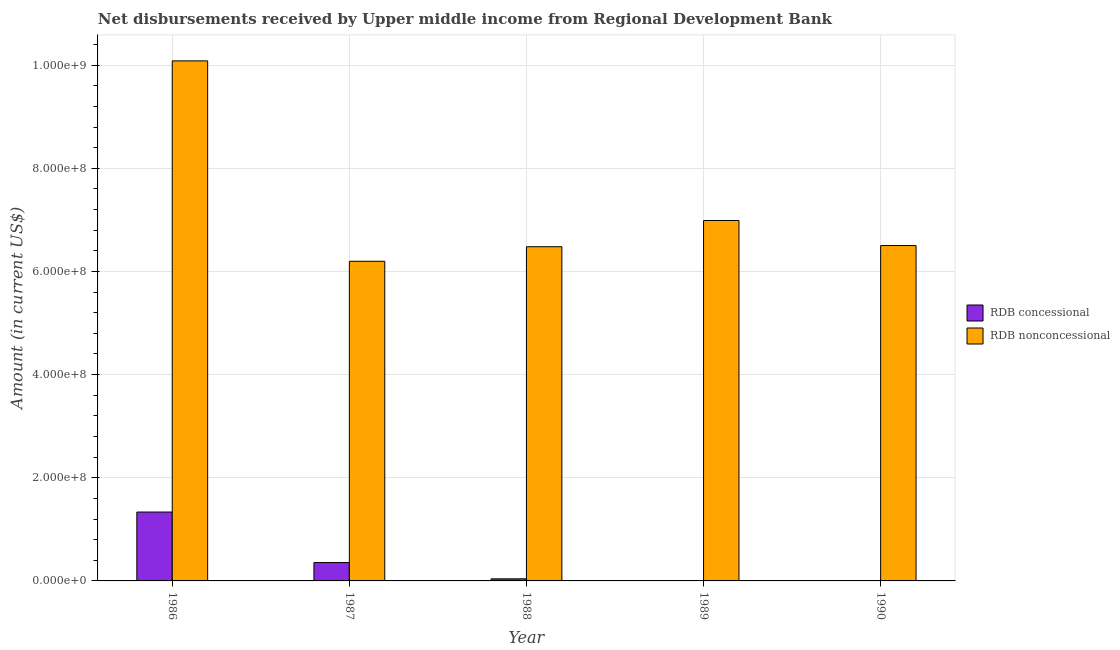How many different coloured bars are there?
Offer a terse response. 2. How many bars are there on the 1st tick from the left?
Provide a succinct answer. 2. In how many cases, is the number of bars for a given year not equal to the number of legend labels?
Ensure brevity in your answer.  2. What is the net concessional disbursements from rdb in 1989?
Offer a very short reply. 0. Across all years, what is the maximum net concessional disbursements from rdb?
Keep it short and to the point. 1.34e+08. Across all years, what is the minimum net concessional disbursements from rdb?
Give a very brief answer. 0. In which year was the net non concessional disbursements from rdb maximum?
Provide a succinct answer. 1986. What is the total net non concessional disbursements from rdb in the graph?
Offer a terse response. 3.62e+09. What is the difference between the net concessional disbursements from rdb in 1986 and that in 1987?
Provide a succinct answer. 9.79e+07. What is the difference between the net non concessional disbursements from rdb in 1988 and the net concessional disbursements from rdb in 1990?
Offer a terse response. -2.28e+06. What is the average net non concessional disbursements from rdb per year?
Ensure brevity in your answer.  7.25e+08. What is the ratio of the net concessional disbursements from rdb in 1987 to that in 1988?
Provide a short and direct response. 8.79. Is the net non concessional disbursements from rdb in 1988 less than that in 1989?
Make the answer very short. Yes. What is the difference between the highest and the second highest net non concessional disbursements from rdb?
Provide a succinct answer. 3.09e+08. What is the difference between the highest and the lowest net concessional disbursements from rdb?
Give a very brief answer. 1.34e+08. Are all the bars in the graph horizontal?
Your answer should be very brief. No. Where does the legend appear in the graph?
Your response must be concise. Center right. How many legend labels are there?
Ensure brevity in your answer.  2. How are the legend labels stacked?
Make the answer very short. Vertical. What is the title of the graph?
Your response must be concise. Net disbursements received by Upper middle income from Regional Development Bank. What is the Amount (in current US$) in RDB concessional in 1986?
Your answer should be compact. 1.34e+08. What is the Amount (in current US$) of RDB nonconcessional in 1986?
Make the answer very short. 1.01e+09. What is the Amount (in current US$) of RDB concessional in 1987?
Make the answer very short. 3.56e+07. What is the Amount (in current US$) of RDB nonconcessional in 1987?
Give a very brief answer. 6.20e+08. What is the Amount (in current US$) in RDB concessional in 1988?
Offer a terse response. 4.05e+06. What is the Amount (in current US$) of RDB nonconcessional in 1988?
Offer a very short reply. 6.48e+08. What is the Amount (in current US$) in RDB nonconcessional in 1989?
Keep it short and to the point. 6.99e+08. What is the Amount (in current US$) in RDB concessional in 1990?
Make the answer very short. 0. What is the Amount (in current US$) of RDB nonconcessional in 1990?
Offer a terse response. 6.50e+08. Across all years, what is the maximum Amount (in current US$) of RDB concessional?
Your response must be concise. 1.34e+08. Across all years, what is the maximum Amount (in current US$) in RDB nonconcessional?
Provide a short and direct response. 1.01e+09. Across all years, what is the minimum Amount (in current US$) in RDB concessional?
Make the answer very short. 0. Across all years, what is the minimum Amount (in current US$) of RDB nonconcessional?
Your answer should be compact. 6.20e+08. What is the total Amount (in current US$) of RDB concessional in the graph?
Offer a very short reply. 1.73e+08. What is the total Amount (in current US$) of RDB nonconcessional in the graph?
Offer a very short reply. 3.62e+09. What is the difference between the Amount (in current US$) in RDB concessional in 1986 and that in 1987?
Offer a terse response. 9.79e+07. What is the difference between the Amount (in current US$) in RDB nonconcessional in 1986 and that in 1987?
Offer a terse response. 3.89e+08. What is the difference between the Amount (in current US$) of RDB concessional in 1986 and that in 1988?
Provide a short and direct response. 1.29e+08. What is the difference between the Amount (in current US$) in RDB nonconcessional in 1986 and that in 1988?
Provide a succinct answer. 3.60e+08. What is the difference between the Amount (in current US$) in RDB nonconcessional in 1986 and that in 1989?
Make the answer very short. 3.09e+08. What is the difference between the Amount (in current US$) of RDB nonconcessional in 1986 and that in 1990?
Your answer should be compact. 3.58e+08. What is the difference between the Amount (in current US$) in RDB concessional in 1987 and that in 1988?
Keep it short and to the point. 3.16e+07. What is the difference between the Amount (in current US$) in RDB nonconcessional in 1987 and that in 1988?
Make the answer very short. -2.82e+07. What is the difference between the Amount (in current US$) in RDB nonconcessional in 1987 and that in 1989?
Make the answer very short. -7.91e+07. What is the difference between the Amount (in current US$) in RDB nonconcessional in 1987 and that in 1990?
Provide a short and direct response. -3.05e+07. What is the difference between the Amount (in current US$) in RDB nonconcessional in 1988 and that in 1989?
Your answer should be very brief. -5.09e+07. What is the difference between the Amount (in current US$) of RDB nonconcessional in 1988 and that in 1990?
Keep it short and to the point. -2.28e+06. What is the difference between the Amount (in current US$) in RDB nonconcessional in 1989 and that in 1990?
Provide a short and direct response. 4.86e+07. What is the difference between the Amount (in current US$) of RDB concessional in 1986 and the Amount (in current US$) of RDB nonconcessional in 1987?
Keep it short and to the point. -4.86e+08. What is the difference between the Amount (in current US$) in RDB concessional in 1986 and the Amount (in current US$) in RDB nonconcessional in 1988?
Provide a short and direct response. -5.14e+08. What is the difference between the Amount (in current US$) of RDB concessional in 1986 and the Amount (in current US$) of RDB nonconcessional in 1989?
Give a very brief answer. -5.65e+08. What is the difference between the Amount (in current US$) in RDB concessional in 1986 and the Amount (in current US$) in RDB nonconcessional in 1990?
Your answer should be very brief. -5.17e+08. What is the difference between the Amount (in current US$) of RDB concessional in 1987 and the Amount (in current US$) of RDB nonconcessional in 1988?
Offer a terse response. -6.12e+08. What is the difference between the Amount (in current US$) of RDB concessional in 1987 and the Amount (in current US$) of RDB nonconcessional in 1989?
Provide a succinct answer. -6.63e+08. What is the difference between the Amount (in current US$) of RDB concessional in 1987 and the Amount (in current US$) of RDB nonconcessional in 1990?
Give a very brief answer. -6.15e+08. What is the difference between the Amount (in current US$) in RDB concessional in 1988 and the Amount (in current US$) in RDB nonconcessional in 1989?
Keep it short and to the point. -6.95e+08. What is the difference between the Amount (in current US$) in RDB concessional in 1988 and the Amount (in current US$) in RDB nonconcessional in 1990?
Keep it short and to the point. -6.46e+08. What is the average Amount (in current US$) in RDB concessional per year?
Your response must be concise. 3.46e+07. What is the average Amount (in current US$) in RDB nonconcessional per year?
Provide a succinct answer. 7.25e+08. In the year 1986, what is the difference between the Amount (in current US$) of RDB concessional and Amount (in current US$) of RDB nonconcessional?
Give a very brief answer. -8.75e+08. In the year 1987, what is the difference between the Amount (in current US$) in RDB concessional and Amount (in current US$) in RDB nonconcessional?
Give a very brief answer. -5.84e+08. In the year 1988, what is the difference between the Amount (in current US$) in RDB concessional and Amount (in current US$) in RDB nonconcessional?
Ensure brevity in your answer.  -6.44e+08. What is the ratio of the Amount (in current US$) in RDB concessional in 1986 to that in 1987?
Offer a terse response. 3.75. What is the ratio of the Amount (in current US$) of RDB nonconcessional in 1986 to that in 1987?
Make the answer very short. 1.63. What is the ratio of the Amount (in current US$) of RDB concessional in 1986 to that in 1988?
Keep it short and to the point. 32.95. What is the ratio of the Amount (in current US$) of RDB nonconcessional in 1986 to that in 1988?
Offer a very short reply. 1.56. What is the ratio of the Amount (in current US$) of RDB nonconcessional in 1986 to that in 1989?
Keep it short and to the point. 1.44. What is the ratio of the Amount (in current US$) in RDB nonconcessional in 1986 to that in 1990?
Ensure brevity in your answer.  1.55. What is the ratio of the Amount (in current US$) in RDB concessional in 1987 to that in 1988?
Provide a succinct answer. 8.79. What is the ratio of the Amount (in current US$) of RDB nonconcessional in 1987 to that in 1988?
Provide a succinct answer. 0.96. What is the ratio of the Amount (in current US$) of RDB nonconcessional in 1987 to that in 1989?
Provide a short and direct response. 0.89. What is the ratio of the Amount (in current US$) of RDB nonconcessional in 1987 to that in 1990?
Offer a very short reply. 0.95. What is the ratio of the Amount (in current US$) in RDB nonconcessional in 1988 to that in 1989?
Make the answer very short. 0.93. What is the ratio of the Amount (in current US$) of RDB nonconcessional in 1988 to that in 1990?
Provide a short and direct response. 1. What is the ratio of the Amount (in current US$) of RDB nonconcessional in 1989 to that in 1990?
Your response must be concise. 1.07. What is the difference between the highest and the second highest Amount (in current US$) of RDB concessional?
Offer a very short reply. 9.79e+07. What is the difference between the highest and the second highest Amount (in current US$) in RDB nonconcessional?
Your response must be concise. 3.09e+08. What is the difference between the highest and the lowest Amount (in current US$) of RDB concessional?
Provide a short and direct response. 1.34e+08. What is the difference between the highest and the lowest Amount (in current US$) in RDB nonconcessional?
Provide a succinct answer. 3.89e+08. 